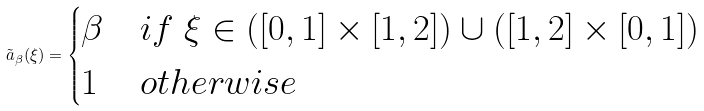<formula> <loc_0><loc_0><loc_500><loc_500>\tilde { a } _ { \beta } ( \xi ) = \begin{cases} \beta & i f \ \xi \in \left ( [ 0 , 1 ] \times [ 1 , 2 ] \right ) \cup \left ( [ 1 , 2 ] \times [ 0 , 1 ] \right ) \\ 1 & o t h e r w i s e \end{cases}</formula> 